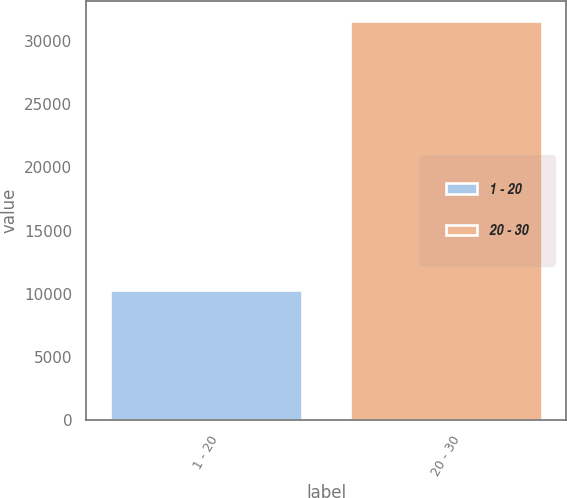Convert chart. <chart><loc_0><loc_0><loc_500><loc_500><bar_chart><fcel>1 - 20<fcel>20 - 30<nl><fcel>10344<fcel>31606<nl></chart> 